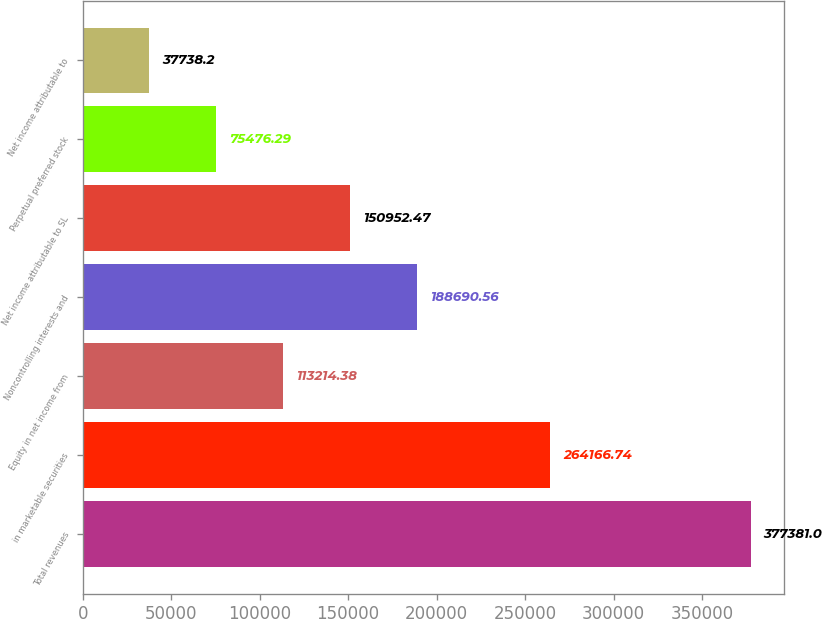<chart> <loc_0><loc_0><loc_500><loc_500><bar_chart><fcel>Total revenues<fcel>in marketable securities<fcel>Equity in net income from<fcel>Noncontrolling interests and<fcel>Net income attributable to SL<fcel>Perpetual preferred stock<fcel>Net income attributable to<nl><fcel>377381<fcel>264167<fcel>113214<fcel>188691<fcel>150952<fcel>75476.3<fcel>37738.2<nl></chart> 